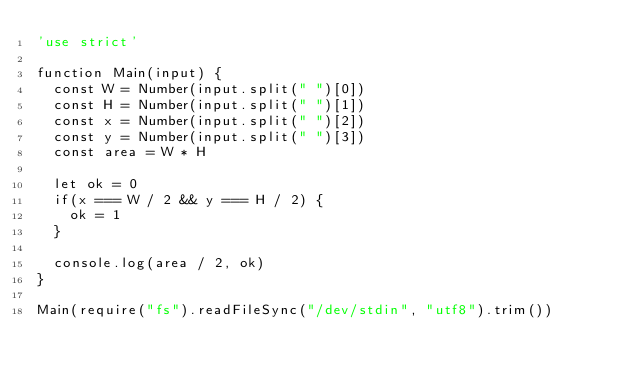Convert code to text. <code><loc_0><loc_0><loc_500><loc_500><_JavaScript_>'use strict'

function Main(input) {
  const W = Number(input.split(" ")[0])
  const H = Number(input.split(" ")[1])
  const x = Number(input.split(" ")[2])
  const y = Number(input.split(" ")[3])
  const area = W * H

  let ok = 0
  if(x === W / 2 && y === H / 2) {
    ok = 1
  }

  console.log(area / 2, ok)
}

Main(require("fs").readFileSync("/dev/stdin", "utf8").trim())</code> 